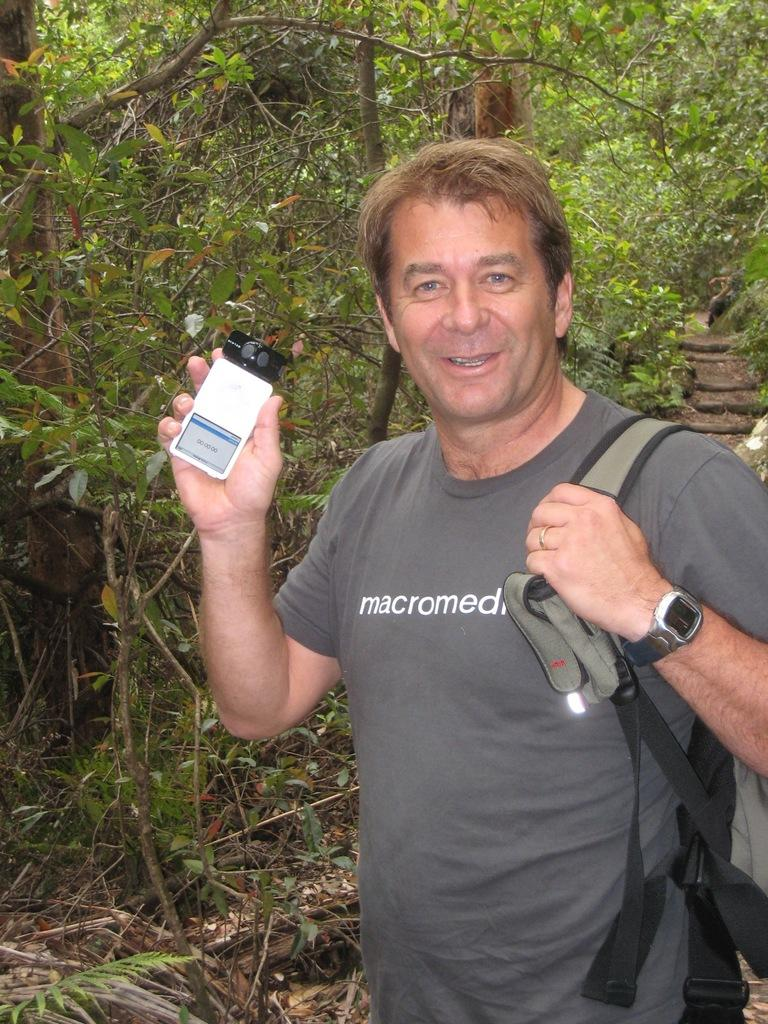What is the person in the image doing? The person is standing in the image and smiling. What is the person holding in the image? The person is holding a device in the image. What can be seen in the background of the image? There are trees visible in the background of the image. What type of bead is the person wearing in the image? There is no bead visible on the person in the image. Who is the owner of the device the person is holding in the image? The image does not provide information about the ownership of the device. 